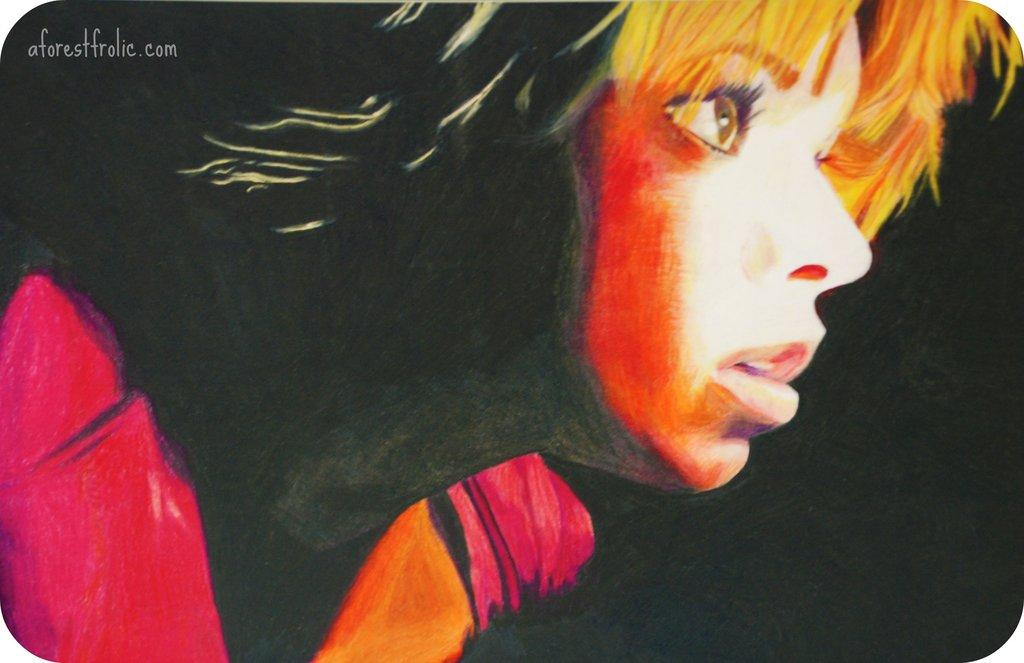What type of artwork is shown in the image? The image is a painting. Who or what is the main subject of the painting? There is a woman depicted in the painting. Are there any additional elements in the painting besides the woman? Yes, there is text present in the painting. Can you see any cobwebs in the painting? There are no cobwebs present in the painting; it is a depiction of a woman and text. What type of verse is written in the painting? There is no verse present in the painting; only text is mentioned. 